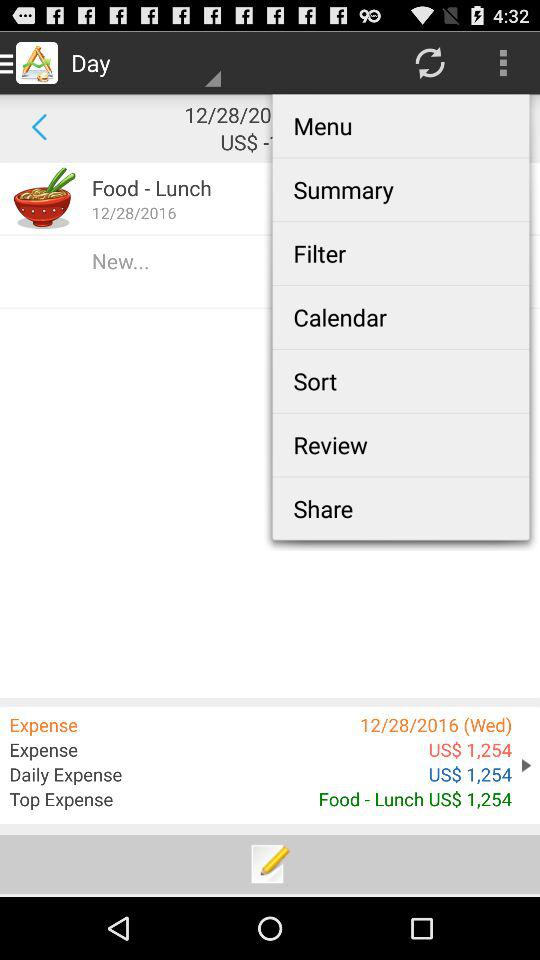What is the expense amount? The expense amount is 1,254 US dollars. 